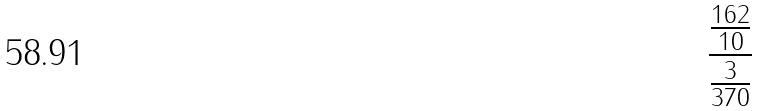<formula> <loc_0><loc_0><loc_500><loc_500>\frac { \frac { 1 6 2 } { 1 0 } } { \frac { 3 } { 3 7 0 } }</formula> 